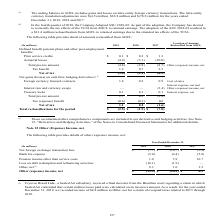According to Sealed Air Corporation's financial document, What was the final decision from the Brazilian court received by Cryovac Brasil Ltda., a Sealed Air subsidiary and the consequence? that certain indirect taxes paid were calculated on an incorrect amount. As a result, for the year ended December 31, 2019, we recorded income of $4.8 million to Other, net for a claim of overpaid taxes related to 2015 through 2018.. The document states: "rt regarding a claim in which Sealed Air contended that certain indirect taxes paid were calculated on an incorrect amount. As a result, for the year ..." Also, What does the table represent? details of other (expense) income, net. The document states: "The following table provides details of other (expense) income, net:..." Also, What is the Other expense, net for 2019? According to the financial document, 19.5 (in millions). The relevant text states: "Other (expense) income, net $ (19.5) $ (18.1) $ 6.2..." Also, can you calculate: Excluding the net for a claim of overpaid taxes related to 2015 through 2018 for 2019, what is the Other, net for 2019? Based on the calculation: 8.3-4.8, the result is 3.5 (in millions). This is based on the information: "Other, net (1) 8.3 1.0 1.2 l losses (4.9) (3.1) (10.0) Total pre-tax amount (4.8) (2.8) (8.7) Other (expense) income, net..." The key data points involved are: 4.8, 8.3. Also, can you calculate: What is the average annual Other expense, net for the 3 years? To answer this question, I need to perform calculations using the financial data. The calculation is: (19.5+18.1-6.2)/3, which equals 10.47 (in millions). This is based on the information: "Other (expense) income, net $ (19.5) $ (18.1) $ 6.2 Other (expense) income, net $ (19.5) $ (18.1) $ 6.2 Other (expense) income, net $ (19.5) $ (18.1) $ 6.2..." The key data points involved are: 18.1, 19.5, 6.2. Also, can you calculate: What is the Net foreign exchange transaction loss expressed as a percentage of othe expense, net for 2019? Based on the calculation: 7.7/19.5, the result is 39.49 (percentage). This is based on the information: "Net foreign exchange transaction loss $ (7.7) $ (16.7) $ (5.9) Other (expense) income, net $ (19.5) $ (18.1) $ 6.2..." The key data points involved are: 19.5, 7.7. 